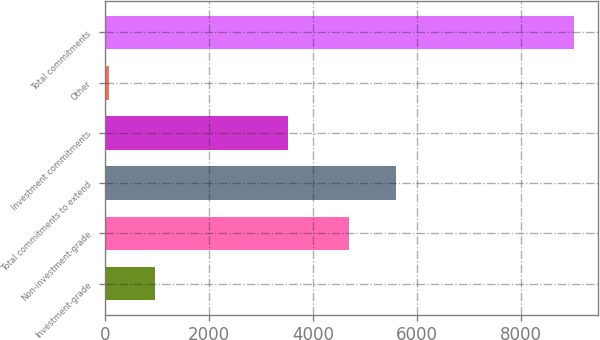Convert chart. <chart><loc_0><loc_0><loc_500><loc_500><bar_chart><fcel>Investment-grade<fcel>Non-investment-grade<fcel>Total commitments to extend<fcel>Investment commitments<fcel>Other<fcel>Total commitments<nl><fcel>964.6<fcel>4693<fcel>5588.6<fcel>3529<fcel>69<fcel>9025<nl></chart> 